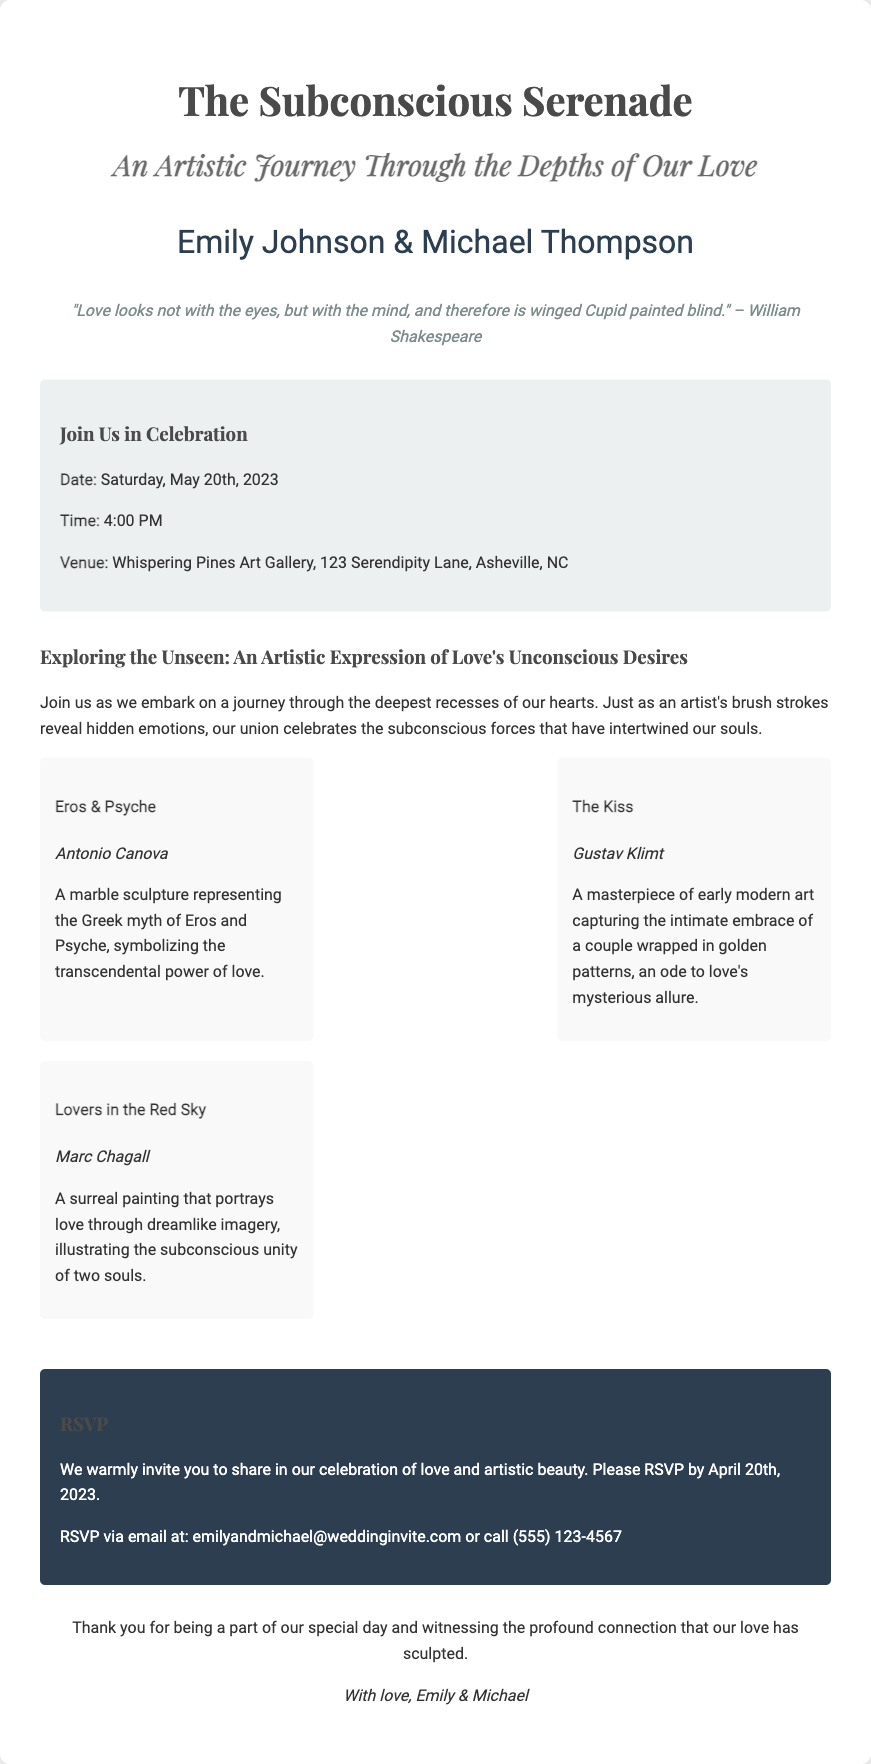What is the title of the wedding invitation? The title is prominently displayed at the top of the document, indicating the theme of the invitation.
Answer: The Subconscious Serenade Who are the couple getting married? The names of the couple are mentioned in a specific area dedicated to them in the invitation.
Answer: Emily Johnson & Michael Thompson What is the date of the wedding? The date is clearly stated in the event details section.
Answer: Saturday, May 20th, 2023 Where is the venue located? The venue address is listed in the event details section, providing the complete location.
Answer: Whispering Pines Art Gallery, 123 Serendipity Lane, Asheville, NC What is the RSVP deadline? The RSVP deadline is mentioned in the RSVP section to inform guests when to respond by.
Answer: April 20th, 2023 Which artwork represents the Greek myth of Eros and Psyche? This question requires recalling information about one of the art pieces listed in the artistic journey section.
Answer: Eros & Psyche What is the time of the wedding? The time is specified in the event details section of the invitation.
Answer: 4:00 PM What is the theme of the artistic journey? The theme is indicated in the title of the respective section that explores deeper meanings of love.
Answer: An Artistic Expression of Love's Unconscious Desires How can guests RSVP? The RSVP section includes specific methods for guests to confirm their attendance.
Answer: Email or call 